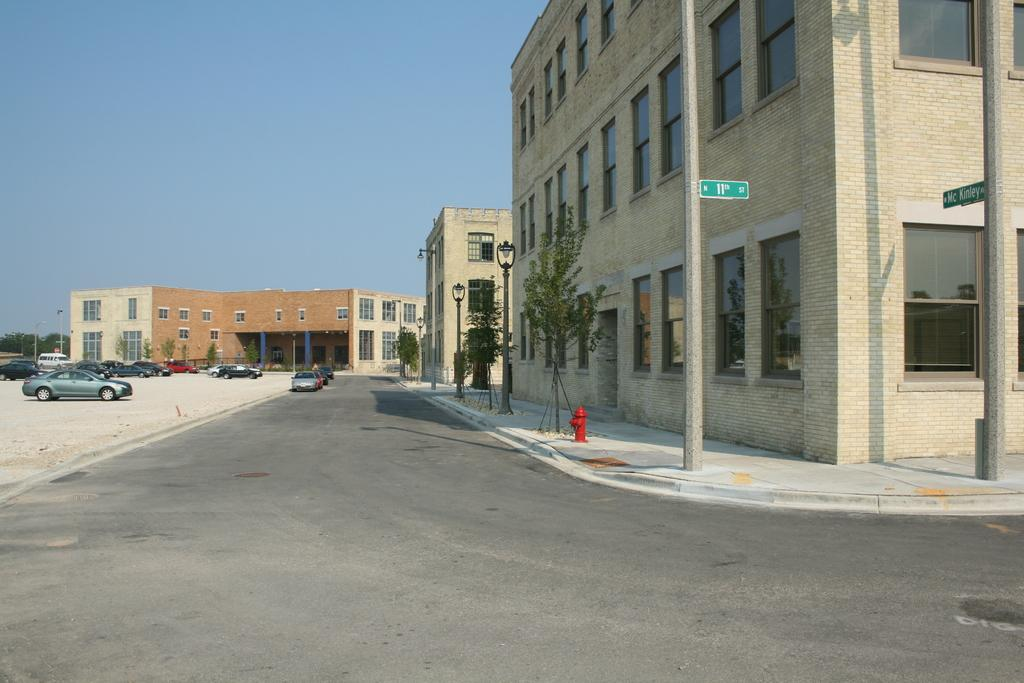What types of objects are present in the image? There are vehicles, light poles, trees, buildings, and glass windows in the image. Can you describe the color of the trees in the image? The trees in the image have a green color. How are the buildings in the image colored? The buildings in the image have brown and cream colors. What is the color of the sky in the image? The sky is blue in the image. Can you tell me how many bombs are present in the image? There are no bombs present in the image. What type of polish is being used on the light poles in the image? There is no indication of any polish being used on the light poles in the image. 